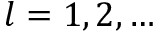Convert formula to latex. <formula><loc_0><loc_0><loc_500><loc_500>l = 1 , 2 , \dots</formula> 